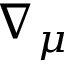Convert formula to latex. <formula><loc_0><loc_0><loc_500><loc_500>\nabla _ { \mu }</formula> 